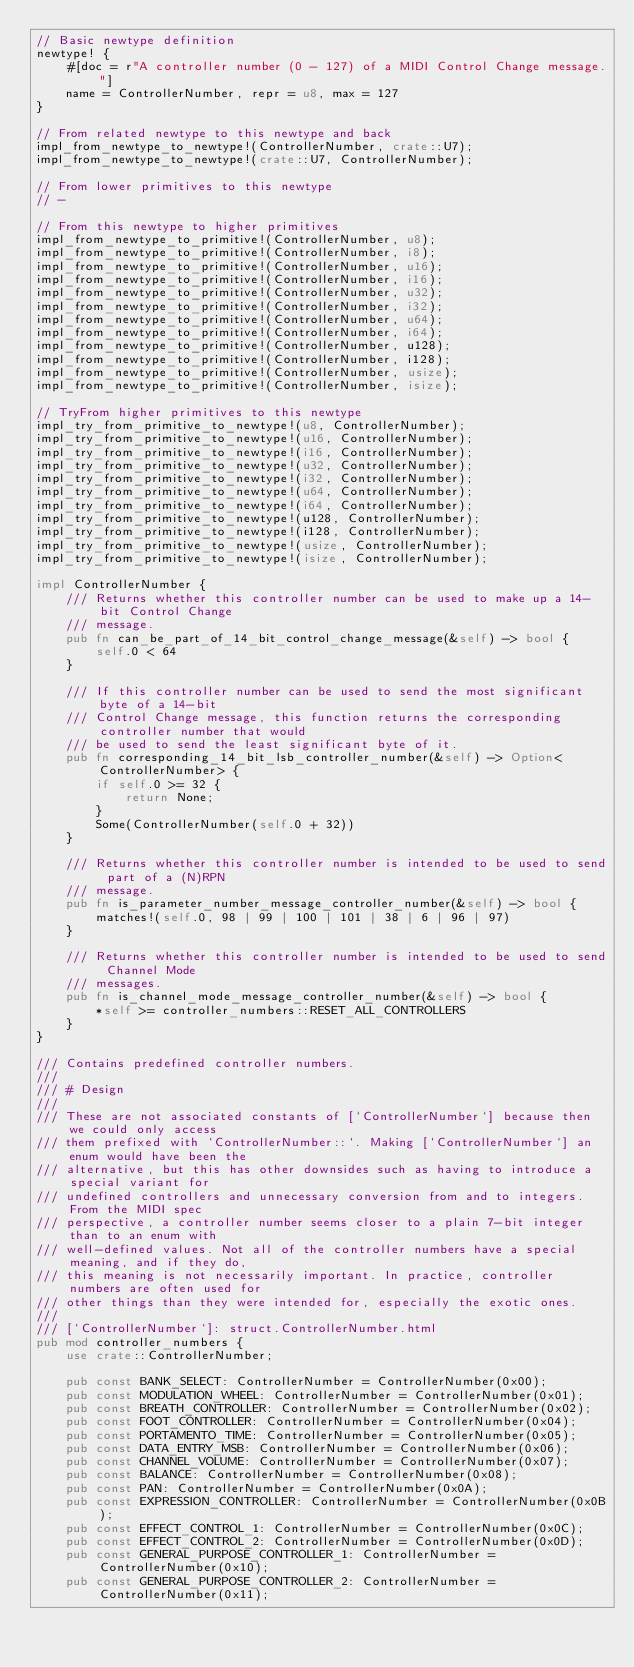Convert code to text. <code><loc_0><loc_0><loc_500><loc_500><_Rust_>// Basic newtype definition
newtype! {
    #[doc = r"A controller number (0 - 127) of a MIDI Control Change message."]
    name = ControllerNumber, repr = u8, max = 127
}

// From related newtype to this newtype and back
impl_from_newtype_to_newtype!(ControllerNumber, crate::U7);
impl_from_newtype_to_newtype!(crate::U7, ControllerNumber);

// From lower primitives to this newtype
// -

// From this newtype to higher primitives
impl_from_newtype_to_primitive!(ControllerNumber, u8);
impl_from_newtype_to_primitive!(ControllerNumber, i8);
impl_from_newtype_to_primitive!(ControllerNumber, u16);
impl_from_newtype_to_primitive!(ControllerNumber, i16);
impl_from_newtype_to_primitive!(ControllerNumber, u32);
impl_from_newtype_to_primitive!(ControllerNumber, i32);
impl_from_newtype_to_primitive!(ControllerNumber, u64);
impl_from_newtype_to_primitive!(ControllerNumber, i64);
impl_from_newtype_to_primitive!(ControllerNumber, u128);
impl_from_newtype_to_primitive!(ControllerNumber, i128);
impl_from_newtype_to_primitive!(ControllerNumber, usize);
impl_from_newtype_to_primitive!(ControllerNumber, isize);

// TryFrom higher primitives to this newtype
impl_try_from_primitive_to_newtype!(u8, ControllerNumber);
impl_try_from_primitive_to_newtype!(u16, ControllerNumber);
impl_try_from_primitive_to_newtype!(i16, ControllerNumber);
impl_try_from_primitive_to_newtype!(u32, ControllerNumber);
impl_try_from_primitive_to_newtype!(i32, ControllerNumber);
impl_try_from_primitive_to_newtype!(u64, ControllerNumber);
impl_try_from_primitive_to_newtype!(i64, ControllerNumber);
impl_try_from_primitive_to_newtype!(u128, ControllerNumber);
impl_try_from_primitive_to_newtype!(i128, ControllerNumber);
impl_try_from_primitive_to_newtype!(usize, ControllerNumber);
impl_try_from_primitive_to_newtype!(isize, ControllerNumber);

impl ControllerNumber {
    /// Returns whether this controller number can be used to make up a 14-bit Control Change
    /// message.
    pub fn can_be_part_of_14_bit_control_change_message(&self) -> bool {
        self.0 < 64
    }

    /// If this controller number can be used to send the most significant byte of a 14-bit
    /// Control Change message, this function returns the corresponding controller number that would
    /// be used to send the least significant byte of it.
    pub fn corresponding_14_bit_lsb_controller_number(&self) -> Option<ControllerNumber> {
        if self.0 >= 32 {
            return None;
        }
        Some(ControllerNumber(self.0 + 32))
    }

    /// Returns whether this controller number is intended to be used to send part of a (N)RPN
    /// message.
    pub fn is_parameter_number_message_controller_number(&self) -> bool {
        matches!(self.0, 98 | 99 | 100 | 101 | 38 | 6 | 96 | 97)
    }

    /// Returns whether this controller number is intended to be used to send Channel Mode
    /// messages.
    pub fn is_channel_mode_message_controller_number(&self) -> bool {
        *self >= controller_numbers::RESET_ALL_CONTROLLERS
    }
}

/// Contains predefined controller numbers.
///
/// # Design
///
/// These are not associated constants of [`ControllerNumber`] because then we could only access
/// them prefixed with `ControllerNumber::`. Making [`ControllerNumber`] an enum would have been the
/// alternative, but this has other downsides such as having to introduce a special variant for
/// undefined controllers and unnecessary conversion from and to integers. From the MIDI spec
/// perspective, a controller number seems closer to a plain 7-bit integer than to an enum with
/// well-defined values. Not all of the controller numbers have a special meaning, and if they do,
/// this meaning is not necessarily important. In practice, controller numbers are often used for
/// other things than they were intended for, especially the exotic ones.
///
/// [`ControllerNumber`]: struct.ControllerNumber.html
pub mod controller_numbers {
    use crate::ControllerNumber;

    pub const BANK_SELECT: ControllerNumber = ControllerNumber(0x00);
    pub const MODULATION_WHEEL: ControllerNumber = ControllerNumber(0x01);
    pub const BREATH_CONTROLLER: ControllerNumber = ControllerNumber(0x02);
    pub const FOOT_CONTROLLER: ControllerNumber = ControllerNumber(0x04);
    pub const PORTAMENTO_TIME: ControllerNumber = ControllerNumber(0x05);
    pub const DATA_ENTRY_MSB: ControllerNumber = ControllerNumber(0x06);
    pub const CHANNEL_VOLUME: ControllerNumber = ControllerNumber(0x07);
    pub const BALANCE: ControllerNumber = ControllerNumber(0x08);
    pub const PAN: ControllerNumber = ControllerNumber(0x0A);
    pub const EXPRESSION_CONTROLLER: ControllerNumber = ControllerNumber(0x0B);
    pub const EFFECT_CONTROL_1: ControllerNumber = ControllerNumber(0x0C);
    pub const EFFECT_CONTROL_2: ControllerNumber = ControllerNumber(0x0D);
    pub const GENERAL_PURPOSE_CONTROLLER_1: ControllerNumber = ControllerNumber(0x10);
    pub const GENERAL_PURPOSE_CONTROLLER_2: ControllerNumber = ControllerNumber(0x11);</code> 